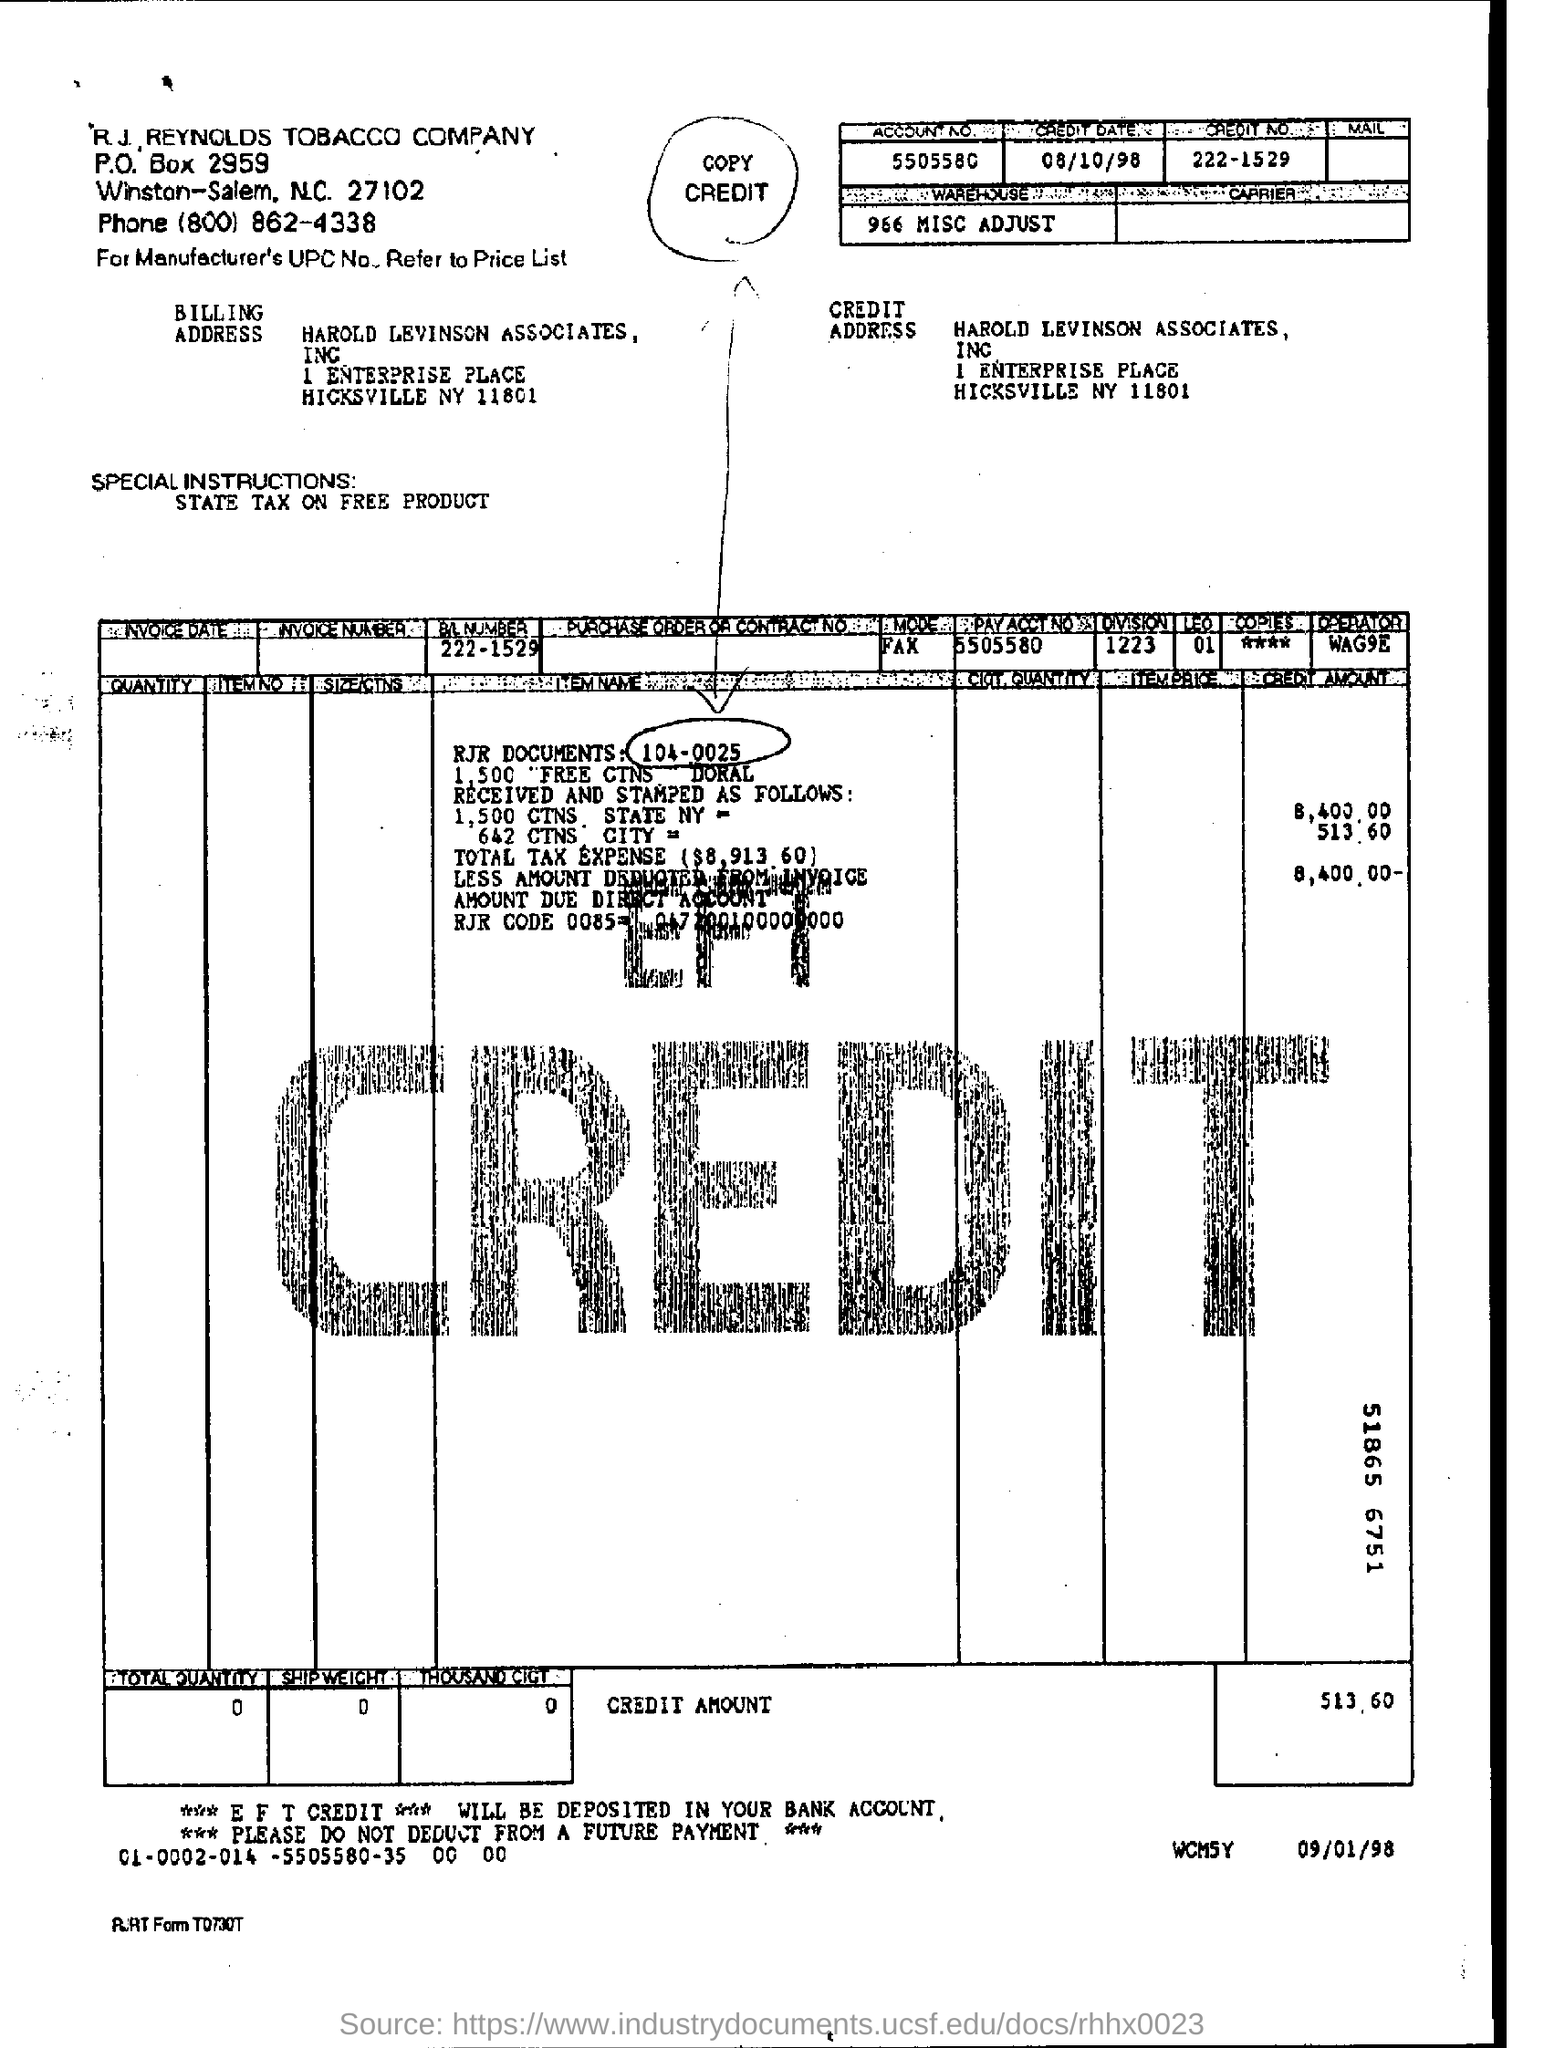Highlight a few significant elements in this photo. The credit number is 222-1529. What is the credit date?" is a question asking for information about the date in question. The date in question is 08/10/98. 